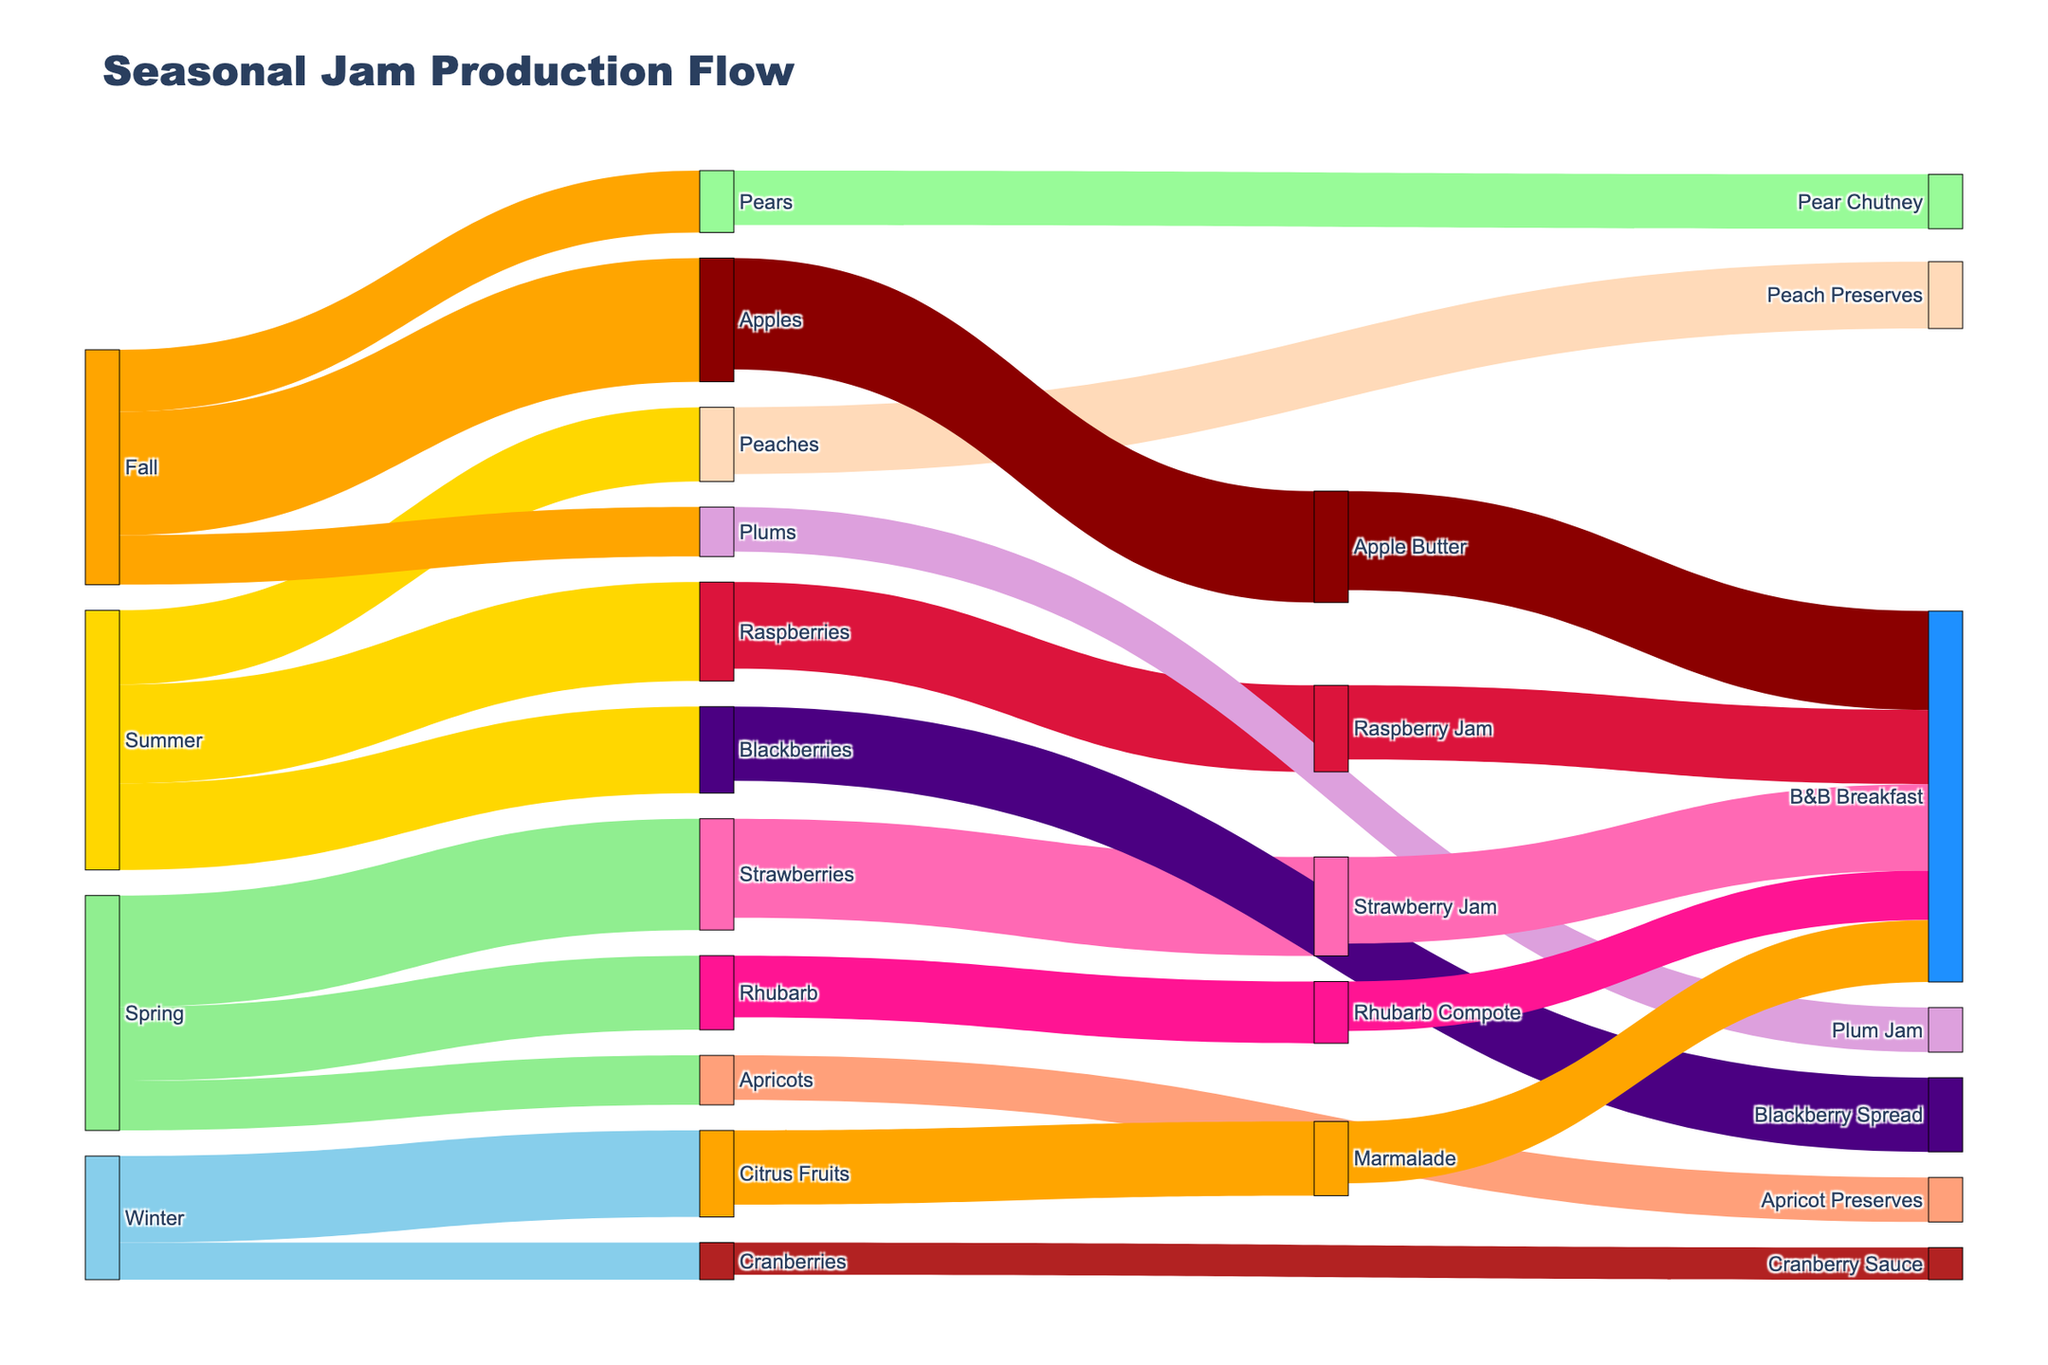What season has the highest total jam ingredient availability? To find out the season with the highest ingredient availability, add up the values corresponding to each season from the figure. Spring has 450 (Strawberries) + 300 (Rhubarb) + 200 (Apricots) = 950. Summer has 400 (Raspberries) + 350 (Blackberries) + 300 (Peaches) = 1050. Fall has 500 (Apples) + 250 (Pears) + 200 (Plums) = 950. Winter has 350 (Citrus Fruits) + 150 (Cranberries) = 500. Summer has the highest availability with a total of 1050.
Answer: Summer How many different jam spreads are produced from summer fruits? Identify the number of unique target spreads connected to sources of summer fruits (Raspberries, Blackberries, Peaches). There are Raspberry Jam (from Raspberries), Blackberry Spread (from Blackberries), and Peach Preserves (from Peaches).
Answer: 3 Which fruit ingredient has the most significant contribution to B&B Breakfast offerings? Look for the highest value linked to B&B Breakfast offerings from fruit spreads. Apple Butter contributes 400, which is higher than any other contribution.
Answer: Apple Butter Compare the production volume of Strawberry Jam and Raspberry Jam. Which one is larger and by how much? Identify the production volumes for Strawberry Jam (400) and Raspberry Jam (350). Subtract the smaller from the larger: 400 - 350 = 50.
Answer: Strawberry Jam by 50 During Fall, which fruit is used the least in jam production? Look for the smallest value among the fruits in Fall: Apples (500), Pears (250), and Plums (200). Plums have the smallest value.
Answer: Plums How much more Strawberry Jam is produced compared to Apricot Preserves in Spring? Identify the production volume for Strawberry Jam (400) and Apricot Preserves (180). Subtract the value of Apricot Preserves from Strawberry Jam: 400 - 180 = 220.
Answer: 220 What is the total amount of spreads produced from winter fruits? Add the values of spreads produced from winter fruits: Marmalade (300) and Cranberry Sauce (130). 300 + 130 = 430.
Answer: 430 What proportion of Rhubarb is used to make Rhubarb Compote compared to its availability in Spring? Find Rhubarb availability in Spring (300) and the amount used for Rhubarb Compote (250). Compute the proportion: 250 / 300 ≈ 0.833 or 83.3%.
Answer: 83.3% Is the production volume of Blackberry Spread greater than Peach Preserves? Compare the production volumes: Blackberry Spread (300) and Peach Preserves (270). Blackberry Spread has a higher volume.
Answer: Yes 